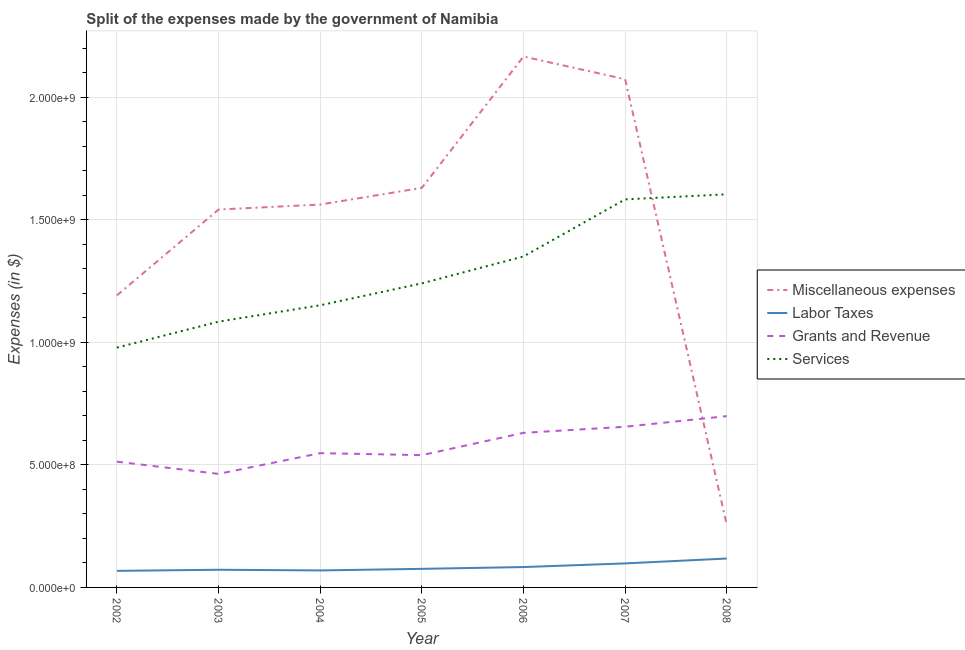What is the amount spent on miscellaneous expenses in 2002?
Ensure brevity in your answer.  1.19e+09. Across all years, what is the maximum amount spent on grants and revenue?
Provide a succinct answer. 6.99e+08. Across all years, what is the minimum amount spent on grants and revenue?
Offer a very short reply. 4.63e+08. In which year was the amount spent on grants and revenue minimum?
Make the answer very short. 2003. What is the total amount spent on labor taxes in the graph?
Ensure brevity in your answer.  5.84e+08. What is the difference between the amount spent on labor taxes in 2002 and that in 2005?
Give a very brief answer. -8.20e+06. What is the difference between the amount spent on services in 2006 and the amount spent on miscellaneous expenses in 2003?
Your response must be concise. -1.91e+08. What is the average amount spent on miscellaneous expenses per year?
Make the answer very short. 1.49e+09. In the year 2007, what is the difference between the amount spent on labor taxes and amount spent on services?
Your answer should be compact. -1.49e+09. What is the ratio of the amount spent on grants and revenue in 2003 to that in 2006?
Provide a short and direct response. 0.73. Is the amount spent on services in 2002 less than that in 2006?
Your response must be concise. Yes. Is the difference between the amount spent on labor taxes in 2004 and 2007 greater than the difference between the amount spent on miscellaneous expenses in 2004 and 2007?
Ensure brevity in your answer.  Yes. What is the difference between the highest and the second highest amount spent on miscellaneous expenses?
Provide a succinct answer. 9.26e+07. What is the difference between the highest and the lowest amount spent on miscellaneous expenses?
Your answer should be compact. 1.91e+09. In how many years, is the amount spent on services greater than the average amount spent on services taken over all years?
Offer a terse response. 3. Is it the case that in every year, the sum of the amount spent on miscellaneous expenses and amount spent on labor taxes is greater than the amount spent on grants and revenue?
Make the answer very short. No. Does the amount spent on services monotonically increase over the years?
Your answer should be compact. Yes. How many lines are there?
Your response must be concise. 4. How many years are there in the graph?
Offer a very short reply. 7. What is the difference between two consecutive major ticks on the Y-axis?
Ensure brevity in your answer.  5.00e+08. Are the values on the major ticks of Y-axis written in scientific E-notation?
Ensure brevity in your answer.  Yes. Does the graph contain any zero values?
Provide a short and direct response. No. Does the graph contain grids?
Your answer should be very brief. Yes. How many legend labels are there?
Your answer should be compact. 4. What is the title of the graph?
Offer a very short reply. Split of the expenses made by the government of Namibia. What is the label or title of the X-axis?
Your answer should be very brief. Year. What is the label or title of the Y-axis?
Provide a short and direct response. Expenses (in $). What is the Expenses (in $) in Miscellaneous expenses in 2002?
Provide a short and direct response. 1.19e+09. What is the Expenses (in $) of Labor Taxes in 2002?
Provide a succinct answer. 6.76e+07. What is the Expenses (in $) in Grants and Revenue in 2002?
Your response must be concise. 5.13e+08. What is the Expenses (in $) of Services in 2002?
Your response must be concise. 9.78e+08. What is the Expenses (in $) of Miscellaneous expenses in 2003?
Make the answer very short. 1.54e+09. What is the Expenses (in $) in Labor Taxes in 2003?
Offer a very short reply. 7.21e+07. What is the Expenses (in $) of Grants and Revenue in 2003?
Offer a terse response. 4.63e+08. What is the Expenses (in $) of Services in 2003?
Offer a very short reply. 1.08e+09. What is the Expenses (in $) in Miscellaneous expenses in 2004?
Provide a short and direct response. 1.56e+09. What is the Expenses (in $) in Labor Taxes in 2004?
Your answer should be very brief. 6.93e+07. What is the Expenses (in $) of Grants and Revenue in 2004?
Provide a succinct answer. 5.48e+08. What is the Expenses (in $) in Services in 2004?
Give a very brief answer. 1.15e+09. What is the Expenses (in $) in Miscellaneous expenses in 2005?
Offer a terse response. 1.63e+09. What is the Expenses (in $) in Labor Taxes in 2005?
Make the answer very short. 7.58e+07. What is the Expenses (in $) in Grants and Revenue in 2005?
Your answer should be compact. 5.40e+08. What is the Expenses (in $) of Services in 2005?
Offer a terse response. 1.24e+09. What is the Expenses (in $) of Miscellaneous expenses in 2006?
Make the answer very short. 2.17e+09. What is the Expenses (in $) of Labor Taxes in 2006?
Give a very brief answer. 8.31e+07. What is the Expenses (in $) of Grants and Revenue in 2006?
Offer a terse response. 6.31e+08. What is the Expenses (in $) of Services in 2006?
Your answer should be compact. 1.35e+09. What is the Expenses (in $) of Miscellaneous expenses in 2007?
Ensure brevity in your answer.  2.07e+09. What is the Expenses (in $) of Labor Taxes in 2007?
Make the answer very short. 9.80e+07. What is the Expenses (in $) of Grants and Revenue in 2007?
Your answer should be compact. 6.56e+08. What is the Expenses (in $) in Services in 2007?
Ensure brevity in your answer.  1.58e+09. What is the Expenses (in $) in Miscellaneous expenses in 2008?
Offer a terse response. 2.55e+08. What is the Expenses (in $) of Labor Taxes in 2008?
Offer a terse response. 1.18e+08. What is the Expenses (in $) of Grants and Revenue in 2008?
Provide a short and direct response. 6.99e+08. What is the Expenses (in $) in Services in 2008?
Your response must be concise. 1.60e+09. Across all years, what is the maximum Expenses (in $) in Miscellaneous expenses?
Provide a succinct answer. 2.17e+09. Across all years, what is the maximum Expenses (in $) of Labor Taxes?
Ensure brevity in your answer.  1.18e+08. Across all years, what is the maximum Expenses (in $) of Grants and Revenue?
Offer a terse response. 6.99e+08. Across all years, what is the maximum Expenses (in $) of Services?
Provide a short and direct response. 1.60e+09. Across all years, what is the minimum Expenses (in $) in Miscellaneous expenses?
Make the answer very short. 2.55e+08. Across all years, what is the minimum Expenses (in $) of Labor Taxes?
Give a very brief answer. 6.76e+07. Across all years, what is the minimum Expenses (in $) in Grants and Revenue?
Provide a short and direct response. 4.63e+08. Across all years, what is the minimum Expenses (in $) of Services?
Offer a very short reply. 9.78e+08. What is the total Expenses (in $) in Miscellaneous expenses in the graph?
Provide a succinct answer. 1.04e+1. What is the total Expenses (in $) in Labor Taxes in the graph?
Give a very brief answer. 5.84e+08. What is the total Expenses (in $) of Grants and Revenue in the graph?
Ensure brevity in your answer.  4.05e+09. What is the total Expenses (in $) of Services in the graph?
Offer a very short reply. 8.99e+09. What is the difference between the Expenses (in $) in Miscellaneous expenses in 2002 and that in 2003?
Offer a terse response. -3.50e+08. What is the difference between the Expenses (in $) in Labor Taxes in 2002 and that in 2003?
Offer a very short reply. -4.50e+06. What is the difference between the Expenses (in $) in Grants and Revenue in 2002 and that in 2003?
Keep it short and to the point. 4.98e+07. What is the difference between the Expenses (in $) of Services in 2002 and that in 2003?
Keep it short and to the point. -1.06e+08. What is the difference between the Expenses (in $) in Miscellaneous expenses in 2002 and that in 2004?
Your answer should be compact. -3.71e+08. What is the difference between the Expenses (in $) of Labor Taxes in 2002 and that in 2004?
Your response must be concise. -1.70e+06. What is the difference between the Expenses (in $) in Grants and Revenue in 2002 and that in 2004?
Give a very brief answer. -3.48e+07. What is the difference between the Expenses (in $) in Services in 2002 and that in 2004?
Provide a succinct answer. -1.73e+08. What is the difference between the Expenses (in $) in Miscellaneous expenses in 2002 and that in 2005?
Offer a very short reply. -4.39e+08. What is the difference between the Expenses (in $) of Labor Taxes in 2002 and that in 2005?
Provide a succinct answer. -8.20e+06. What is the difference between the Expenses (in $) in Grants and Revenue in 2002 and that in 2005?
Keep it short and to the point. -2.66e+07. What is the difference between the Expenses (in $) of Services in 2002 and that in 2005?
Offer a very short reply. -2.62e+08. What is the difference between the Expenses (in $) in Miscellaneous expenses in 2002 and that in 2006?
Make the answer very short. -9.74e+08. What is the difference between the Expenses (in $) in Labor Taxes in 2002 and that in 2006?
Give a very brief answer. -1.55e+07. What is the difference between the Expenses (in $) of Grants and Revenue in 2002 and that in 2006?
Offer a terse response. -1.18e+08. What is the difference between the Expenses (in $) of Services in 2002 and that in 2006?
Your answer should be very brief. -3.72e+08. What is the difference between the Expenses (in $) in Miscellaneous expenses in 2002 and that in 2007?
Provide a short and direct response. -8.82e+08. What is the difference between the Expenses (in $) in Labor Taxes in 2002 and that in 2007?
Provide a succinct answer. -3.04e+07. What is the difference between the Expenses (in $) of Grants and Revenue in 2002 and that in 2007?
Your response must be concise. -1.42e+08. What is the difference between the Expenses (in $) in Services in 2002 and that in 2007?
Provide a succinct answer. -6.05e+08. What is the difference between the Expenses (in $) in Miscellaneous expenses in 2002 and that in 2008?
Give a very brief answer. 9.36e+08. What is the difference between the Expenses (in $) in Labor Taxes in 2002 and that in 2008?
Your answer should be compact. -5.03e+07. What is the difference between the Expenses (in $) in Grants and Revenue in 2002 and that in 2008?
Keep it short and to the point. -1.86e+08. What is the difference between the Expenses (in $) in Services in 2002 and that in 2008?
Offer a very short reply. -6.25e+08. What is the difference between the Expenses (in $) of Miscellaneous expenses in 2003 and that in 2004?
Offer a terse response. -2.04e+07. What is the difference between the Expenses (in $) of Labor Taxes in 2003 and that in 2004?
Your response must be concise. 2.80e+06. What is the difference between the Expenses (in $) of Grants and Revenue in 2003 and that in 2004?
Give a very brief answer. -8.46e+07. What is the difference between the Expenses (in $) in Services in 2003 and that in 2004?
Provide a short and direct response. -6.68e+07. What is the difference between the Expenses (in $) in Miscellaneous expenses in 2003 and that in 2005?
Give a very brief answer. -8.84e+07. What is the difference between the Expenses (in $) in Labor Taxes in 2003 and that in 2005?
Your answer should be compact. -3.70e+06. What is the difference between the Expenses (in $) in Grants and Revenue in 2003 and that in 2005?
Offer a very short reply. -7.64e+07. What is the difference between the Expenses (in $) of Services in 2003 and that in 2005?
Your answer should be very brief. -1.56e+08. What is the difference between the Expenses (in $) in Miscellaneous expenses in 2003 and that in 2006?
Provide a short and direct response. -6.24e+08. What is the difference between the Expenses (in $) of Labor Taxes in 2003 and that in 2006?
Provide a short and direct response. -1.10e+07. What is the difference between the Expenses (in $) in Grants and Revenue in 2003 and that in 2006?
Give a very brief answer. -1.67e+08. What is the difference between the Expenses (in $) in Services in 2003 and that in 2006?
Your answer should be very brief. -2.66e+08. What is the difference between the Expenses (in $) of Miscellaneous expenses in 2003 and that in 2007?
Provide a short and direct response. -5.32e+08. What is the difference between the Expenses (in $) in Labor Taxes in 2003 and that in 2007?
Provide a succinct answer. -2.59e+07. What is the difference between the Expenses (in $) in Grants and Revenue in 2003 and that in 2007?
Give a very brief answer. -1.92e+08. What is the difference between the Expenses (in $) in Services in 2003 and that in 2007?
Give a very brief answer. -4.99e+08. What is the difference between the Expenses (in $) in Miscellaneous expenses in 2003 and that in 2008?
Offer a terse response. 1.29e+09. What is the difference between the Expenses (in $) of Labor Taxes in 2003 and that in 2008?
Provide a short and direct response. -4.58e+07. What is the difference between the Expenses (in $) in Grants and Revenue in 2003 and that in 2008?
Give a very brief answer. -2.36e+08. What is the difference between the Expenses (in $) in Services in 2003 and that in 2008?
Provide a short and direct response. -5.20e+08. What is the difference between the Expenses (in $) in Miscellaneous expenses in 2004 and that in 2005?
Make the answer very short. -6.80e+07. What is the difference between the Expenses (in $) in Labor Taxes in 2004 and that in 2005?
Your response must be concise. -6.50e+06. What is the difference between the Expenses (in $) of Grants and Revenue in 2004 and that in 2005?
Give a very brief answer. 8.20e+06. What is the difference between the Expenses (in $) of Services in 2004 and that in 2005?
Your answer should be compact. -8.94e+07. What is the difference between the Expenses (in $) of Miscellaneous expenses in 2004 and that in 2006?
Offer a terse response. -6.04e+08. What is the difference between the Expenses (in $) in Labor Taxes in 2004 and that in 2006?
Offer a terse response. -1.38e+07. What is the difference between the Expenses (in $) in Grants and Revenue in 2004 and that in 2006?
Your answer should be compact. -8.28e+07. What is the difference between the Expenses (in $) in Services in 2004 and that in 2006?
Offer a very short reply. -1.99e+08. What is the difference between the Expenses (in $) in Miscellaneous expenses in 2004 and that in 2007?
Provide a succinct answer. -5.11e+08. What is the difference between the Expenses (in $) of Labor Taxes in 2004 and that in 2007?
Offer a very short reply. -2.87e+07. What is the difference between the Expenses (in $) in Grants and Revenue in 2004 and that in 2007?
Ensure brevity in your answer.  -1.08e+08. What is the difference between the Expenses (in $) of Services in 2004 and that in 2007?
Offer a terse response. -4.32e+08. What is the difference between the Expenses (in $) in Miscellaneous expenses in 2004 and that in 2008?
Provide a succinct answer. 1.31e+09. What is the difference between the Expenses (in $) of Labor Taxes in 2004 and that in 2008?
Your response must be concise. -4.86e+07. What is the difference between the Expenses (in $) in Grants and Revenue in 2004 and that in 2008?
Offer a very short reply. -1.51e+08. What is the difference between the Expenses (in $) in Services in 2004 and that in 2008?
Your response must be concise. -4.53e+08. What is the difference between the Expenses (in $) of Miscellaneous expenses in 2005 and that in 2006?
Offer a very short reply. -5.36e+08. What is the difference between the Expenses (in $) in Labor Taxes in 2005 and that in 2006?
Offer a terse response. -7.30e+06. What is the difference between the Expenses (in $) of Grants and Revenue in 2005 and that in 2006?
Give a very brief answer. -9.10e+07. What is the difference between the Expenses (in $) in Services in 2005 and that in 2006?
Your answer should be very brief. -1.10e+08. What is the difference between the Expenses (in $) of Miscellaneous expenses in 2005 and that in 2007?
Your response must be concise. -4.43e+08. What is the difference between the Expenses (in $) of Labor Taxes in 2005 and that in 2007?
Your response must be concise. -2.22e+07. What is the difference between the Expenses (in $) in Grants and Revenue in 2005 and that in 2007?
Provide a short and direct response. -1.16e+08. What is the difference between the Expenses (in $) of Services in 2005 and that in 2007?
Your response must be concise. -3.43e+08. What is the difference between the Expenses (in $) in Miscellaneous expenses in 2005 and that in 2008?
Keep it short and to the point. 1.37e+09. What is the difference between the Expenses (in $) in Labor Taxes in 2005 and that in 2008?
Your answer should be compact. -4.21e+07. What is the difference between the Expenses (in $) in Grants and Revenue in 2005 and that in 2008?
Your answer should be very brief. -1.59e+08. What is the difference between the Expenses (in $) of Services in 2005 and that in 2008?
Offer a very short reply. -3.63e+08. What is the difference between the Expenses (in $) of Miscellaneous expenses in 2006 and that in 2007?
Make the answer very short. 9.26e+07. What is the difference between the Expenses (in $) in Labor Taxes in 2006 and that in 2007?
Your answer should be compact. -1.49e+07. What is the difference between the Expenses (in $) in Grants and Revenue in 2006 and that in 2007?
Your answer should be very brief. -2.49e+07. What is the difference between the Expenses (in $) of Services in 2006 and that in 2007?
Keep it short and to the point. -2.33e+08. What is the difference between the Expenses (in $) in Miscellaneous expenses in 2006 and that in 2008?
Keep it short and to the point. 1.91e+09. What is the difference between the Expenses (in $) of Labor Taxes in 2006 and that in 2008?
Provide a short and direct response. -3.48e+07. What is the difference between the Expenses (in $) of Grants and Revenue in 2006 and that in 2008?
Make the answer very short. -6.82e+07. What is the difference between the Expenses (in $) of Services in 2006 and that in 2008?
Keep it short and to the point. -2.54e+08. What is the difference between the Expenses (in $) in Miscellaneous expenses in 2007 and that in 2008?
Make the answer very short. 1.82e+09. What is the difference between the Expenses (in $) of Labor Taxes in 2007 and that in 2008?
Offer a very short reply. -1.99e+07. What is the difference between the Expenses (in $) in Grants and Revenue in 2007 and that in 2008?
Provide a succinct answer. -4.33e+07. What is the difference between the Expenses (in $) of Services in 2007 and that in 2008?
Offer a very short reply. -2.07e+07. What is the difference between the Expenses (in $) of Miscellaneous expenses in 2002 and the Expenses (in $) of Labor Taxes in 2003?
Make the answer very short. 1.12e+09. What is the difference between the Expenses (in $) of Miscellaneous expenses in 2002 and the Expenses (in $) of Grants and Revenue in 2003?
Provide a succinct answer. 7.28e+08. What is the difference between the Expenses (in $) of Miscellaneous expenses in 2002 and the Expenses (in $) of Services in 2003?
Offer a very short reply. 1.07e+08. What is the difference between the Expenses (in $) in Labor Taxes in 2002 and the Expenses (in $) in Grants and Revenue in 2003?
Provide a succinct answer. -3.96e+08. What is the difference between the Expenses (in $) of Labor Taxes in 2002 and the Expenses (in $) of Services in 2003?
Give a very brief answer. -1.02e+09. What is the difference between the Expenses (in $) in Grants and Revenue in 2002 and the Expenses (in $) in Services in 2003?
Offer a very short reply. -5.71e+08. What is the difference between the Expenses (in $) in Miscellaneous expenses in 2002 and the Expenses (in $) in Labor Taxes in 2004?
Your response must be concise. 1.12e+09. What is the difference between the Expenses (in $) of Miscellaneous expenses in 2002 and the Expenses (in $) of Grants and Revenue in 2004?
Your response must be concise. 6.44e+08. What is the difference between the Expenses (in $) of Miscellaneous expenses in 2002 and the Expenses (in $) of Services in 2004?
Provide a short and direct response. 4.05e+07. What is the difference between the Expenses (in $) in Labor Taxes in 2002 and the Expenses (in $) in Grants and Revenue in 2004?
Make the answer very short. -4.80e+08. What is the difference between the Expenses (in $) in Labor Taxes in 2002 and the Expenses (in $) in Services in 2004?
Your response must be concise. -1.08e+09. What is the difference between the Expenses (in $) of Grants and Revenue in 2002 and the Expenses (in $) of Services in 2004?
Your answer should be very brief. -6.38e+08. What is the difference between the Expenses (in $) in Miscellaneous expenses in 2002 and the Expenses (in $) in Labor Taxes in 2005?
Offer a very short reply. 1.12e+09. What is the difference between the Expenses (in $) of Miscellaneous expenses in 2002 and the Expenses (in $) of Grants and Revenue in 2005?
Your response must be concise. 6.52e+08. What is the difference between the Expenses (in $) of Miscellaneous expenses in 2002 and the Expenses (in $) of Services in 2005?
Give a very brief answer. -4.89e+07. What is the difference between the Expenses (in $) of Labor Taxes in 2002 and the Expenses (in $) of Grants and Revenue in 2005?
Offer a very short reply. -4.72e+08. What is the difference between the Expenses (in $) of Labor Taxes in 2002 and the Expenses (in $) of Services in 2005?
Provide a short and direct response. -1.17e+09. What is the difference between the Expenses (in $) of Grants and Revenue in 2002 and the Expenses (in $) of Services in 2005?
Offer a terse response. -7.28e+08. What is the difference between the Expenses (in $) of Miscellaneous expenses in 2002 and the Expenses (in $) of Labor Taxes in 2006?
Make the answer very short. 1.11e+09. What is the difference between the Expenses (in $) in Miscellaneous expenses in 2002 and the Expenses (in $) in Grants and Revenue in 2006?
Give a very brief answer. 5.61e+08. What is the difference between the Expenses (in $) in Miscellaneous expenses in 2002 and the Expenses (in $) in Services in 2006?
Give a very brief answer. -1.59e+08. What is the difference between the Expenses (in $) of Labor Taxes in 2002 and the Expenses (in $) of Grants and Revenue in 2006?
Give a very brief answer. -5.63e+08. What is the difference between the Expenses (in $) of Labor Taxes in 2002 and the Expenses (in $) of Services in 2006?
Give a very brief answer. -1.28e+09. What is the difference between the Expenses (in $) in Grants and Revenue in 2002 and the Expenses (in $) in Services in 2006?
Your answer should be compact. -8.37e+08. What is the difference between the Expenses (in $) in Miscellaneous expenses in 2002 and the Expenses (in $) in Labor Taxes in 2007?
Your response must be concise. 1.09e+09. What is the difference between the Expenses (in $) of Miscellaneous expenses in 2002 and the Expenses (in $) of Grants and Revenue in 2007?
Give a very brief answer. 5.36e+08. What is the difference between the Expenses (in $) of Miscellaneous expenses in 2002 and the Expenses (in $) of Services in 2007?
Provide a short and direct response. -3.92e+08. What is the difference between the Expenses (in $) in Labor Taxes in 2002 and the Expenses (in $) in Grants and Revenue in 2007?
Make the answer very short. -5.88e+08. What is the difference between the Expenses (in $) of Labor Taxes in 2002 and the Expenses (in $) of Services in 2007?
Ensure brevity in your answer.  -1.52e+09. What is the difference between the Expenses (in $) in Grants and Revenue in 2002 and the Expenses (in $) in Services in 2007?
Provide a succinct answer. -1.07e+09. What is the difference between the Expenses (in $) in Miscellaneous expenses in 2002 and the Expenses (in $) in Labor Taxes in 2008?
Give a very brief answer. 1.07e+09. What is the difference between the Expenses (in $) in Miscellaneous expenses in 2002 and the Expenses (in $) in Grants and Revenue in 2008?
Your response must be concise. 4.93e+08. What is the difference between the Expenses (in $) of Miscellaneous expenses in 2002 and the Expenses (in $) of Services in 2008?
Make the answer very short. -4.12e+08. What is the difference between the Expenses (in $) in Labor Taxes in 2002 and the Expenses (in $) in Grants and Revenue in 2008?
Provide a short and direct response. -6.31e+08. What is the difference between the Expenses (in $) of Labor Taxes in 2002 and the Expenses (in $) of Services in 2008?
Offer a terse response. -1.54e+09. What is the difference between the Expenses (in $) of Grants and Revenue in 2002 and the Expenses (in $) of Services in 2008?
Provide a short and direct response. -1.09e+09. What is the difference between the Expenses (in $) in Miscellaneous expenses in 2003 and the Expenses (in $) in Labor Taxes in 2004?
Keep it short and to the point. 1.47e+09. What is the difference between the Expenses (in $) in Miscellaneous expenses in 2003 and the Expenses (in $) in Grants and Revenue in 2004?
Provide a short and direct response. 9.94e+08. What is the difference between the Expenses (in $) of Miscellaneous expenses in 2003 and the Expenses (in $) of Services in 2004?
Provide a succinct answer. 3.91e+08. What is the difference between the Expenses (in $) of Labor Taxes in 2003 and the Expenses (in $) of Grants and Revenue in 2004?
Your response must be concise. -4.76e+08. What is the difference between the Expenses (in $) in Labor Taxes in 2003 and the Expenses (in $) in Services in 2004?
Offer a very short reply. -1.08e+09. What is the difference between the Expenses (in $) in Grants and Revenue in 2003 and the Expenses (in $) in Services in 2004?
Offer a very short reply. -6.88e+08. What is the difference between the Expenses (in $) of Miscellaneous expenses in 2003 and the Expenses (in $) of Labor Taxes in 2005?
Your answer should be very brief. 1.47e+09. What is the difference between the Expenses (in $) in Miscellaneous expenses in 2003 and the Expenses (in $) in Grants and Revenue in 2005?
Provide a succinct answer. 1.00e+09. What is the difference between the Expenses (in $) of Miscellaneous expenses in 2003 and the Expenses (in $) of Services in 2005?
Your response must be concise. 3.01e+08. What is the difference between the Expenses (in $) in Labor Taxes in 2003 and the Expenses (in $) in Grants and Revenue in 2005?
Keep it short and to the point. -4.68e+08. What is the difference between the Expenses (in $) of Labor Taxes in 2003 and the Expenses (in $) of Services in 2005?
Ensure brevity in your answer.  -1.17e+09. What is the difference between the Expenses (in $) in Grants and Revenue in 2003 and the Expenses (in $) in Services in 2005?
Provide a succinct answer. -7.77e+08. What is the difference between the Expenses (in $) of Miscellaneous expenses in 2003 and the Expenses (in $) of Labor Taxes in 2006?
Provide a short and direct response. 1.46e+09. What is the difference between the Expenses (in $) of Miscellaneous expenses in 2003 and the Expenses (in $) of Grants and Revenue in 2006?
Make the answer very short. 9.11e+08. What is the difference between the Expenses (in $) of Miscellaneous expenses in 2003 and the Expenses (in $) of Services in 2006?
Your answer should be very brief. 1.91e+08. What is the difference between the Expenses (in $) of Labor Taxes in 2003 and the Expenses (in $) of Grants and Revenue in 2006?
Ensure brevity in your answer.  -5.59e+08. What is the difference between the Expenses (in $) of Labor Taxes in 2003 and the Expenses (in $) of Services in 2006?
Offer a terse response. -1.28e+09. What is the difference between the Expenses (in $) of Grants and Revenue in 2003 and the Expenses (in $) of Services in 2006?
Give a very brief answer. -8.87e+08. What is the difference between the Expenses (in $) in Miscellaneous expenses in 2003 and the Expenses (in $) in Labor Taxes in 2007?
Ensure brevity in your answer.  1.44e+09. What is the difference between the Expenses (in $) of Miscellaneous expenses in 2003 and the Expenses (in $) of Grants and Revenue in 2007?
Keep it short and to the point. 8.86e+08. What is the difference between the Expenses (in $) in Miscellaneous expenses in 2003 and the Expenses (in $) in Services in 2007?
Keep it short and to the point. -4.14e+07. What is the difference between the Expenses (in $) in Labor Taxes in 2003 and the Expenses (in $) in Grants and Revenue in 2007?
Make the answer very short. -5.84e+08. What is the difference between the Expenses (in $) in Labor Taxes in 2003 and the Expenses (in $) in Services in 2007?
Your answer should be very brief. -1.51e+09. What is the difference between the Expenses (in $) in Grants and Revenue in 2003 and the Expenses (in $) in Services in 2007?
Your response must be concise. -1.12e+09. What is the difference between the Expenses (in $) in Miscellaneous expenses in 2003 and the Expenses (in $) in Labor Taxes in 2008?
Make the answer very short. 1.42e+09. What is the difference between the Expenses (in $) of Miscellaneous expenses in 2003 and the Expenses (in $) of Grants and Revenue in 2008?
Your response must be concise. 8.43e+08. What is the difference between the Expenses (in $) in Miscellaneous expenses in 2003 and the Expenses (in $) in Services in 2008?
Keep it short and to the point. -6.21e+07. What is the difference between the Expenses (in $) in Labor Taxes in 2003 and the Expenses (in $) in Grants and Revenue in 2008?
Provide a short and direct response. -6.27e+08. What is the difference between the Expenses (in $) of Labor Taxes in 2003 and the Expenses (in $) of Services in 2008?
Ensure brevity in your answer.  -1.53e+09. What is the difference between the Expenses (in $) in Grants and Revenue in 2003 and the Expenses (in $) in Services in 2008?
Provide a short and direct response. -1.14e+09. What is the difference between the Expenses (in $) of Miscellaneous expenses in 2004 and the Expenses (in $) of Labor Taxes in 2005?
Keep it short and to the point. 1.49e+09. What is the difference between the Expenses (in $) in Miscellaneous expenses in 2004 and the Expenses (in $) in Grants and Revenue in 2005?
Make the answer very short. 1.02e+09. What is the difference between the Expenses (in $) of Miscellaneous expenses in 2004 and the Expenses (in $) of Services in 2005?
Provide a succinct answer. 3.22e+08. What is the difference between the Expenses (in $) in Labor Taxes in 2004 and the Expenses (in $) in Grants and Revenue in 2005?
Give a very brief answer. -4.70e+08. What is the difference between the Expenses (in $) in Labor Taxes in 2004 and the Expenses (in $) in Services in 2005?
Offer a terse response. -1.17e+09. What is the difference between the Expenses (in $) of Grants and Revenue in 2004 and the Expenses (in $) of Services in 2005?
Make the answer very short. -6.93e+08. What is the difference between the Expenses (in $) in Miscellaneous expenses in 2004 and the Expenses (in $) in Labor Taxes in 2006?
Provide a short and direct response. 1.48e+09. What is the difference between the Expenses (in $) in Miscellaneous expenses in 2004 and the Expenses (in $) in Grants and Revenue in 2006?
Keep it short and to the point. 9.32e+08. What is the difference between the Expenses (in $) in Miscellaneous expenses in 2004 and the Expenses (in $) in Services in 2006?
Ensure brevity in your answer.  2.12e+08. What is the difference between the Expenses (in $) of Labor Taxes in 2004 and the Expenses (in $) of Grants and Revenue in 2006?
Your response must be concise. -5.61e+08. What is the difference between the Expenses (in $) in Labor Taxes in 2004 and the Expenses (in $) in Services in 2006?
Offer a very short reply. -1.28e+09. What is the difference between the Expenses (in $) in Grants and Revenue in 2004 and the Expenses (in $) in Services in 2006?
Your response must be concise. -8.02e+08. What is the difference between the Expenses (in $) of Miscellaneous expenses in 2004 and the Expenses (in $) of Labor Taxes in 2007?
Make the answer very short. 1.46e+09. What is the difference between the Expenses (in $) in Miscellaneous expenses in 2004 and the Expenses (in $) in Grants and Revenue in 2007?
Give a very brief answer. 9.07e+08. What is the difference between the Expenses (in $) in Miscellaneous expenses in 2004 and the Expenses (in $) in Services in 2007?
Ensure brevity in your answer.  -2.11e+07. What is the difference between the Expenses (in $) of Labor Taxes in 2004 and the Expenses (in $) of Grants and Revenue in 2007?
Make the answer very short. -5.86e+08. What is the difference between the Expenses (in $) of Labor Taxes in 2004 and the Expenses (in $) of Services in 2007?
Keep it short and to the point. -1.51e+09. What is the difference between the Expenses (in $) of Grants and Revenue in 2004 and the Expenses (in $) of Services in 2007?
Keep it short and to the point. -1.04e+09. What is the difference between the Expenses (in $) in Miscellaneous expenses in 2004 and the Expenses (in $) in Labor Taxes in 2008?
Offer a very short reply. 1.44e+09. What is the difference between the Expenses (in $) in Miscellaneous expenses in 2004 and the Expenses (in $) in Grants and Revenue in 2008?
Keep it short and to the point. 8.63e+08. What is the difference between the Expenses (in $) in Miscellaneous expenses in 2004 and the Expenses (in $) in Services in 2008?
Provide a succinct answer. -4.17e+07. What is the difference between the Expenses (in $) in Labor Taxes in 2004 and the Expenses (in $) in Grants and Revenue in 2008?
Your answer should be compact. -6.30e+08. What is the difference between the Expenses (in $) of Labor Taxes in 2004 and the Expenses (in $) of Services in 2008?
Your answer should be compact. -1.53e+09. What is the difference between the Expenses (in $) in Grants and Revenue in 2004 and the Expenses (in $) in Services in 2008?
Your answer should be compact. -1.06e+09. What is the difference between the Expenses (in $) in Miscellaneous expenses in 2005 and the Expenses (in $) in Labor Taxes in 2006?
Give a very brief answer. 1.55e+09. What is the difference between the Expenses (in $) of Miscellaneous expenses in 2005 and the Expenses (in $) of Grants and Revenue in 2006?
Give a very brief answer. 1.00e+09. What is the difference between the Expenses (in $) of Miscellaneous expenses in 2005 and the Expenses (in $) of Services in 2006?
Your answer should be very brief. 2.80e+08. What is the difference between the Expenses (in $) in Labor Taxes in 2005 and the Expenses (in $) in Grants and Revenue in 2006?
Give a very brief answer. -5.55e+08. What is the difference between the Expenses (in $) of Labor Taxes in 2005 and the Expenses (in $) of Services in 2006?
Offer a very short reply. -1.27e+09. What is the difference between the Expenses (in $) of Grants and Revenue in 2005 and the Expenses (in $) of Services in 2006?
Provide a short and direct response. -8.11e+08. What is the difference between the Expenses (in $) in Miscellaneous expenses in 2005 and the Expenses (in $) in Labor Taxes in 2007?
Provide a succinct answer. 1.53e+09. What is the difference between the Expenses (in $) of Miscellaneous expenses in 2005 and the Expenses (in $) of Grants and Revenue in 2007?
Provide a short and direct response. 9.75e+08. What is the difference between the Expenses (in $) of Miscellaneous expenses in 2005 and the Expenses (in $) of Services in 2007?
Ensure brevity in your answer.  4.70e+07. What is the difference between the Expenses (in $) in Labor Taxes in 2005 and the Expenses (in $) in Grants and Revenue in 2007?
Give a very brief answer. -5.80e+08. What is the difference between the Expenses (in $) of Labor Taxes in 2005 and the Expenses (in $) of Services in 2007?
Offer a terse response. -1.51e+09. What is the difference between the Expenses (in $) of Grants and Revenue in 2005 and the Expenses (in $) of Services in 2007?
Your answer should be very brief. -1.04e+09. What is the difference between the Expenses (in $) of Miscellaneous expenses in 2005 and the Expenses (in $) of Labor Taxes in 2008?
Provide a succinct answer. 1.51e+09. What is the difference between the Expenses (in $) of Miscellaneous expenses in 2005 and the Expenses (in $) of Grants and Revenue in 2008?
Provide a succinct answer. 9.31e+08. What is the difference between the Expenses (in $) of Miscellaneous expenses in 2005 and the Expenses (in $) of Services in 2008?
Your answer should be very brief. 2.63e+07. What is the difference between the Expenses (in $) in Labor Taxes in 2005 and the Expenses (in $) in Grants and Revenue in 2008?
Your answer should be compact. -6.23e+08. What is the difference between the Expenses (in $) in Labor Taxes in 2005 and the Expenses (in $) in Services in 2008?
Offer a very short reply. -1.53e+09. What is the difference between the Expenses (in $) of Grants and Revenue in 2005 and the Expenses (in $) of Services in 2008?
Make the answer very short. -1.06e+09. What is the difference between the Expenses (in $) in Miscellaneous expenses in 2006 and the Expenses (in $) in Labor Taxes in 2007?
Your answer should be very brief. 2.07e+09. What is the difference between the Expenses (in $) of Miscellaneous expenses in 2006 and the Expenses (in $) of Grants and Revenue in 2007?
Offer a very short reply. 1.51e+09. What is the difference between the Expenses (in $) in Miscellaneous expenses in 2006 and the Expenses (in $) in Services in 2007?
Provide a succinct answer. 5.83e+08. What is the difference between the Expenses (in $) of Labor Taxes in 2006 and the Expenses (in $) of Grants and Revenue in 2007?
Ensure brevity in your answer.  -5.72e+08. What is the difference between the Expenses (in $) in Labor Taxes in 2006 and the Expenses (in $) in Services in 2007?
Provide a short and direct response. -1.50e+09. What is the difference between the Expenses (in $) in Grants and Revenue in 2006 and the Expenses (in $) in Services in 2007?
Give a very brief answer. -9.53e+08. What is the difference between the Expenses (in $) of Miscellaneous expenses in 2006 and the Expenses (in $) of Labor Taxes in 2008?
Your answer should be compact. 2.05e+09. What is the difference between the Expenses (in $) of Miscellaneous expenses in 2006 and the Expenses (in $) of Grants and Revenue in 2008?
Make the answer very short. 1.47e+09. What is the difference between the Expenses (in $) in Miscellaneous expenses in 2006 and the Expenses (in $) in Services in 2008?
Your answer should be very brief. 5.62e+08. What is the difference between the Expenses (in $) in Labor Taxes in 2006 and the Expenses (in $) in Grants and Revenue in 2008?
Offer a terse response. -6.16e+08. What is the difference between the Expenses (in $) of Labor Taxes in 2006 and the Expenses (in $) of Services in 2008?
Give a very brief answer. -1.52e+09. What is the difference between the Expenses (in $) in Grants and Revenue in 2006 and the Expenses (in $) in Services in 2008?
Provide a short and direct response. -9.73e+08. What is the difference between the Expenses (in $) in Miscellaneous expenses in 2007 and the Expenses (in $) in Labor Taxes in 2008?
Give a very brief answer. 1.96e+09. What is the difference between the Expenses (in $) in Miscellaneous expenses in 2007 and the Expenses (in $) in Grants and Revenue in 2008?
Your response must be concise. 1.37e+09. What is the difference between the Expenses (in $) of Miscellaneous expenses in 2007 and the Expenses (in $) of Services in 2008?
Ensure brevity in your answer.  4.69e+08. What is the difference between the Expenses (in $) of Labor Taxes in 2007 and the Expenses (in $) of Grants and Revenue in 2008?
Provide a succinct answer. -6.01e+08. What is the difference between the Expenses (in $) of Labor Taxes in 2007 and the Expenses (in $) of Services in 2008?
Ensure brevity in your answer.  -1.51e+09. What is the difference between the Expenses (in $) of Grants and Revenue in 2007 and the Expenses (in $) of Services in 2008?
Offer a very short reply. -9.48e+08. What is the average Expenses (in $) of Miscellaneous expenses per year?
Give a very brief answer. 1.49e+09. What is the average Expenses (in $) in Labor Taxes per year?
Your answer should be compact. 8.34e+07. What is the average Expenses (in $) of Grants and Revenue per year?
Provide a succinct answer. 5.78e+08. What is the average Expenses (in $) of Services per year?
Ensure brevity in your answer.  1.28e+09. In the year 2002, what is the difference between the Expenses (in $) in Miscellaneous expenses and Expenses (in $) in Labor Taxes?
Provide a succinct answer. 1.12e+09. In the year 2002, what is the difference between the Expenses (in $) of Miscellaneous expenses and Expenses (in $) of Grants and Revenue?
Ensure brevity in your answer.  6.79e+08. In the year 2002, what is the difference between the Expenses (in $) in Miscellaneous expenses and Expenses (in $) in Services?
Your answer should be compact. 2.13e+08. In the year 2002, what is the difference between the Expenses (in $) of Labor Taxes and Expenses (in $) of Grants and Revenue?
Your response must be concise. -4.46e+08. In the year 2002, what is the difference between the Expenses (in $) of Labor Taxes and Expenses (in $) of Services?
Keep it short and to the point. -9.11e+08. In the year 2002, what is the difference between the Expenses (in $) of Grants and Revenue and Expenses (in $) of Services?
Provide a short and direct response. -4.65e+08. In the year 2003, what is the difference between the Expenses (in $) in Miscellaneous expenses and Expenses (in $) in Labor Taxes?
Provide a short and direct response. 1.47e+09. In the year 2003, what is the difference between the Expenses (in $) in Miscellaneous expenses and Expenses (in $) in Grants and Revenue?
Make the answer very short. 1.08e+09. In the year 2003, what is the difference between the Expenses (in $) of Miscellaneous expenses and Expenses (in $) of Services?
Your answer should be compact. 4.57e+08. In the year 2003, what is the difference between the Expenses (in $) in Labor Taxes and Expenses (in $) in Grants and Revenue?
Your answer should be very brief. -3.91e+08. In the year 2003, what is the difference between the Expenses (in $) of Labor Taxes and Expenses (in $) of Services?
Your answer should be very brief. -1.01e+09. In the year 2003, what is the difference between the Expenses (in $) of Grants and Revenue and Expenses (in $) of Services?
Offer a terse response. -6.21e+08. In the year 2004, what is the difference between the Expenses (in $) of Miscellaneous expenses and Expenses (in $) of Labor Taxes?
Your answer should be very brief. 1.49e+09. In the year 2004, what is the difference between the Expenses (in $) of Miscellaneous expenses and Expenses (in $) of Grants and Revenue?
Offer a very short reply. 1.01e+09. In the year 2004, what is the difference between the Expenses (in $) of Miscellaneous expenses and Expenses (in $) of Services?
Your answer should be very brief. 4.11e+08. In the year 2004, what is the difference between the Expenses (in $) in Labor Taxes and Expenses (in $) in Grants and Revenue?
Make the answer very short. -4.79e+08. In the year 2004, what is the difference between the Expenses (in $) in Labor Taxes and Expenses (in $) in Services?
Make the answer very short. -1.08e+09. In the year 2004, what is the difference between the Expenses (in $) of Grants and Revenue and Expenses (in $) of Services?
Provide a short and direct response. -6.03e+08. In the year 2005, what is the difference between the Expenses (in $) of Miscellaneous expenses and Expenses (in $) of Labor Taxes?
Your answer should be compact. 1.55e+09. In the year 2005, what is the difference between the Expenses (in $) in Miscellaneous expenses and Expenses (in $) in Grants and Revenue?
Provide a short and direct response. 1.09e+09. In the year 2005, what is the difference between the Expenses (in $) in Miscellaneous expenses and Expenses (in $) in Services?
Your answer should be compact. 3.90e+08. In the year 2005, what is the difference between the Expenses (in $) of Labor Taxes and Expenses (in $) of Grants and Revenue?
Your response must be concise. -4.64e+08. In the year 2005, what is the difference between the Expenses (in $) of Labor Taxes and Expenses (in $) of Services?
Make the answer very short. -1.16e+09. In the year 2005, what is the difference between the Expenses (in $) in Grants and Revenue and Expenses (in $) in Services?
Make the answer very short. -7.01e+08. In the year 2006, what is the difference between the Expenses (in $) in Miscellaneous expenses and Expenses (in $) in Labor Taxes?
Your answer should be compact. 2.08e+09. In the year 2006, what is the difference between the Expenses (in $) of Miscellaneous expenses and Expenses (in $) of Grants and Revenue?
Your answer should be compact. 1.54e+09. In the year 2006, what is the difference between the Expenses (in $) of Miscellaneous expenses and Expenses (in $) of Services?
Provide a short and direct response. 8.16e+08. In the year 2006, what is the difference between the Expenses (in $) of Labor Taxes and Expenses (in $) of Grants and Revenue?
Your answer should be compact. -5.48e+08. In the year 2006, what is the difference between the Expenses (in $) of Labor Taxes and Expenses (in $) of Services?
Ensure brevity in your answer.  -1.27e+09. In the year 2006, what is the difference between the Expenses (in $) of Grants and Revenue and Expenses (in $) of Services?
Give a very brief answer. -7.20e+08. In the year 2007, what is the difference between the Expenses (in $) in Miscellaneous expenses and Expenses (in $) in Labor Taxes?
Keep it short and to the point. 1.98e+09. In the year 2007, what is the difference between the Expenses (in $) in Miscellaneous expenses and Expenses (in $) in Grants and Revenue?
Offer a very short reply. 1.42e+09. In the year 2007, what is the difference between the Expenses (in $) in Miscellaneous expenses and Expenses (in $) in Services?
Keep it short and to the point. 4.90e+08. In the year 2007, what is the difference between the Expenses (in $) in Labor Taxes and Expenses (in $) in Grants and Revenue?
Offer a terse response. -5.58e+08. In the year 2007, what is the difference between the Expenses (in $) of Labor Taxes and Expenses (in $) of Services?
Provide a short and direct response. -1.49e+09. In the year 2007, what is the difference between the Expenses (in $) in Grants and Revenue and Expenses (in $) in Services?
Provide a succinct answer. -9.28e+08. In the year 2008, what is the difference between the Expenses (in $) of Miscellaneous expenses and Expenses (in $) of Labor Taxes?
Keep it short and to the point. 1.38e+08. In the year 2008, what is the difference between the Expenses (in $) in Miscellaneous expenses and Expenses (in $) in Grants and Revenue?
Your answer should be compact. -4.43e+08. In the year 2008, what is the difference between the Expenses (in $) of Miscellaneous expenses and Expenses (in $) of Services?
Offer a very short reply. -1.35e+09. In the year 2008, what is the difference between the Expenses (in $) of Labor Taxes and Expenses (in $) of Grants and Revenue?
Offer a terse response. -5.81e+08. In the year 2008, what is the difference between the Expenses (in $) of Labor Taxes and Expenses (in $) of Services?
Provide a succinct answer. -1.49e+09. In the year 2008, what is the difference between the Expenses (in $) of Grants and Revenue and Expenses (in $) of Services?
Ensure brevity in your answer.  -9.05e+08. What is the ratio of the Expenses (in $) of Miscellaneous expenses in 2002 to that in 2003?
Provide a short and direct response. 0.77. What is the ratio of the Expenses (in $) in Labor Taxes in 2002 to that in 2003?
Offer a very short reply. 0.94. What is the ratio of the Expenses (in $) of Grants and Revenue in 2002 to that in 2003?
Your response must be concise. 1.11. What is the ratio of the Expenses (in $) in Services in 2002 to that in 2003?
Provide a short and direct response. 0.9. What is the ratio of the Expenses (in $) in Miscellaneous expenses in 2002 to that in 2004?
Offer a terse response. 0.76. What is the ratio of the Expenses (in $) in Labor Taxes in 2002 to that in 2004?
Keep it short and to the point. 0.98. What is the ratio of the Expenses (in $) in Grants and Revenue in 2002 to that in 2004?
Offer a very short reply. 0.94. What is the ratio of the Expenses (in $) in Miscellaneous expenses in 2002 to that in 2005?
Provide a succinct answer. 0.73. What is the ratio of the Expenses (in $) in Labor Taxes in 2002 to that in 2005?
Make the answer very short. 0.89. What is the ratio of the Expenses (in $) of Grants and Revenue in 2002 to that in 2005?
Provide a succinct answer. 0.95. What is the ratio of the Expenses (in $) in Services in 2002 to that in 2005?
Offer a terse response. 0.79. What is the ratio of the Expenses (in $) of Miscellaneous expenses in 2002 to that in 2006?
Offer a very short reply. 0.55. What is the ratio of the Expenses (in $) in Labor Taxes in 2002 to that in 2006?
Ensure brevity in your answer.  0.81. What is the ratio of the Expenses (in $) in Grants and Revenue in 2002 to that in 2006?
Offer a terse response. 0.81. What is the ratio of the Expenses (in $) in Services in 2002 to that in 2006?
Give a very brief answer. 0.72. What is the ratio of the Expenses (in $) of Miscellaneous expenses in 2002 to that in 2007?
Make the answer very short. 0.57. What is the ratio of the Expenses (in $) in Labor Taxes in 2002 to that in 2007?
Your response must be concise. 0.69. What is the ratio of the Expenses (in $) of Grants and Revenue in 2002 to that in 2007?
Offer a very short reply. 0.78. What is the ratio of the Expenses (in $) of Services in 2002 to that in 2007?
Offer a very short reply. 0.62. What is the ratio of the Expenses (in $) in Miscellaneous expenses in 2002 to that in 2008?
Ensure brevity in your answer.  4.67. What is the ratio of the Expenses (in $) in Labor Taxes in 2002 to that in 2008?
Offer a terse response. 0.57. What is the ratio of the Expenses (in $) of Grants and Revenue in 2002 to that in 2008?
Your answer should be very brief. 0.73. What is the ratio of the Expenses (in $) of Services in 2002 to that in 2008?
Make the answer very short. 0.61. What is the ratio of the Expenses (in $) of Miscellaneous expenses in 2003 to that in 2004?
Offer a terse response. 0.99. What is the ratio of the Expenses (in $) of Labor Taxes in 2003 to that in 2004?
Provide a short and direct response. 1.04. What is the ratio of the Expenses (in $) in Grants and Revenue in 2003 to that in 2004?
Keep it short and to the point. 0.85. What is the ratio of the Expenses (in $) in Services in 2003 to that in 2004?
Your response must be concise. 0.94. What is the ratio of the Expenses (in $) of Miscellaneous expenses in 2003 to that in 2005?
Make the answer very short. 0.95. What is the ratio of the Expenses (in $) in Labor Taxes in 2003 to that in 2005?
Your answer should be very brief. 0.95. What is the ratio of the Expenses (in $) in Grants and Revenue in 2003 to that in 2005?
Your response must be concise. 0.86. What is the ratio of the Expenses (in $) of Services in 2003 to that in 2005?
Make the answer very short. 0.87. What is the ratio of the Expenses (in $) of Miscellaneous expenses in 2003 to that in 2006?
Offer a very short reply. 0.71. What is the ratio of the Expenses (in $) of Labor Taxes in 2003 to that in 2006?
Ensure brevity in your answer.  0.87. What is the ratio of the Expenses (in $) in Grants and Revenue in 2003 to that in 2006?
Give a very brief answer. 0.73. What is the ratio of the Expenses (in $) in Services in 2003 to that in 2006?
Your answer should be very brief. 0.8. What is the ratio of the Expenses (in $) of Miscellaneous expenses in 2003 to that in 2007?
Ensure brevity in your answer.  0.74. What is the ratio of the Expenses (in $) in Labor Taxes in 2003 to that in 2007?
Give a very brief answer. 0.74. What is the ratio of the Expenses (in $) in Grants and Revenue in 2003 to that in 2007?
Offer a very short reply. 0.71. What is the ratio of the Expenses (in $) in Services in 2003 to that in 2007?
Provide a short and direct response. 0.68. What is the ratio of the Expenses (in $) in Miscellaneous expenses in 2003 to that in 2008?
Provide a short and direct response. 6.04. What is the ratio of the Expenses (in $) in Labor Taxes in 2003 to that in 2008?
Make the answer very short. 0.61. What is the ratio of the Expenses (in $) in Grants and Revenue in 2003 to that in 2008?
Ensure brevity in your answer.  0.66. What is the ratio of the Expenses (in $) in Services in 2003 to that in 2008?
Your response must be concise. 0.68. What is the ratio of the Expenses (in $) of Labor Taxes in 2004 to that in 2005?
Make the answer very short. 0.91. What is the ratio of the Expenses (in $) of Grants and Revenue in 2004 to that in 2005?
Your answer should be very brief. 1.02. What is the ratio of the Expenses (in $) in Services in 2004 to that in 2005?
Provide a succinct answer. 0.93. What is the ratio of the Expenses (in $) of Miscellaneous expenses in 2004 to that in 2006?
Your response must be concise. 0.72. What is the ratio of the Expenses (in $) of Labor Taxes in 2004 to that in 2006?
Make the answer very short. 0.83. What is the ratio of the Expenses (in $) in Grants and Revenue in 2004 to that in 2006?
Provide a short and direct response. 0.87. What is the ratio of the Expenses (in $) in Services in 2004 to that in 2006?
Your answer should be very brief. 0.85. What is the ratio of the Expenses (in $) in Miscellaneous expenses in 2004 to that in 2007?
Your answer should be very brief. 0.75. What is the ratio of the Expenses (in $) of Labor Taxes in 2004 to that in 2007?
Offer a terse response. 0.71. What is the ratio of the Expenses (in $) in Grants and Revenue in 2004 to that in 2007?
Ensure brevity in your answer.  0.84. What is the ratio of the Expenses (in $) in Services in 2004 to that in 2007?
Your response must be concise. 0.73. What is the ratio of the Expenses (in $) in Miscellaneous expenses in 2004 to that in 2008?
Your answer should be very brief. 6.12. What is the ratio of the Expenses (in $) in Labor Taxes in 2004 to that in 2008?
Your answer should be very brief. 0.59. What is the ratio of the Expenses (in $) of Grants and Revenue in 2004 to that in 2008?
Provide a short and direct response. 0.78. What is the ratio of the Expenses (in $) of Services in 2004 to that in 2008?
Keep it short and to the point. 0.72. What is the ratio of the Expenses (in $) in Miscellaneous expenses in 2005 to that in 2006?
Give a very brief answer. 0.75. What is the ratio of the Expenses (in $) of Labor Taxes in 2005 to that in 2006?
Offer a very short reply. 0.91. What is the ratio of the Expenses (in $) of Grants and Revenue in 2005 to that in 2006?
Keep it short and to the point. 0.86. What is the ratio of the Expenses (in $) in Services in 2005 to that in 2006?
Your answer should be very brief. 0.92. What is the ratio of the Expenses (in $) in Miscellaneous expenses in 2005 to that in 2007?
Make the answer very short. 0.79. What is the ratio of the Expenses (in $) of Labor Taxes in 2005 to that in 2007?
Offer a very short reply. 0.77. What is the ratio of the Expenses (in $) of Grants and Revenue in 2005 to that in 2007?
Your answer should be very brief. 0.82. What is the ratio of the Expenses (in $) in Services in 2005 to that in 2007?
Offer a terse response. 0.78. What is the ratio of the Expenses (in $) of Miscellaneous expenses in 2005 to that in 2008?
Your answer should be very brief. 6.38. What is the ratio of the Expenses (in $) in Labor Taxes in 2005 to that in 2008?
Offer a very short reply. 0.64. What is the ratio of the Expenses (in $) of Grants and Revenue in 2005 to that in 2008?
Provide a succinct answer. 0.77. What is the ratio of the Expenses (in $) of Services in 2005 to that in 2008?
Offer a very short reply. 0.77. What is the ratio of the Expenses (in $) of Miscellaneous expenses in 2006 to that in 2007?
Provide a short and direct response. 1.04. What is the ratio of the Expenses (in $) of Labor Taxes in 2006 to that in 2007?
Your answer should be very brief. 0.85. What is the ratio of the Expenses (in $) in Grants and Revenue in 2006 to that in 2007?
Provide a succinct answer. 0.96. What is the ratio of the Expenses (in $) of Services in 2006 to that in 2007?
Your answer should be compact. 0.85. What is the ratio of the Expenses (in $) in Miscellaneous expenses in 2006 to that in 2008?
Offer a very short reply. 8.48. What is the ratio of the Expenses (in $) in Labor Taxes in 2006 to that in 2008?
Your answer should be very brief. 0.7. What is the ratio of the Expenses (in $) of Grants and Revenue in 2006 to that in 2008?
Provide a short and direct response. 0.9. What is the ratio of the Expenses (in $) of Services in 2006 to that in 2008?
Offer a terse response. 0.84. What is the ratio of the Expenses (in $) in Miscellaneous expenses in 2007 to that in 2008?
Your answer should be compact. 8.12. What is the ratio of the Expenses (in $) of Labor Taxes in 2007 to that in 2008?
Provide a succinct answer. 0.83. What is the ratio of the Expenses (in $) in Grants and Revenue in 2007 to that in 2008?
Ensure brevity in your answer.  0.94. What is the ratio of the Expenses (in $) of Services in 2007 to that in 2008?
Your response must be concise. 0.99. What is the difference between the highest and the second highest Expenses (in $) of Miscellaneous expenses?
Keep it short and to the point. 9.26e+07. What is the difference between the highest and the second highest Expenses (in $) of Labor Taxes?
Provide a short and direct response. 1.99e+07. What is the difference between the highest and the second highest Expenses (in $) in Grants and Revenue?
Give a very brief answer. 4.33e+07. What is the difference between the highest and the second highest Expenses (in $) in Services?
Your response must be concise. 2.07e+07. What is the difference between the highest and the lowest Expenses (in $) in Miscellaneous expenses?
Provide a short and direct response. 1.91e+09. What is the difference between the highest and the lowest Expenses (in $) in Labor Taxes?
Give a very brief answer. 5.03e+07. What is the difference between the highest and the lowest Expenses (in $) in Grants and Revenue?
Your answer should be compact. 2.36e+08. What is the difference between the highest and the lowest Expenses (in $) in Services?
Provide a succinct answer. 6.25e+08. 